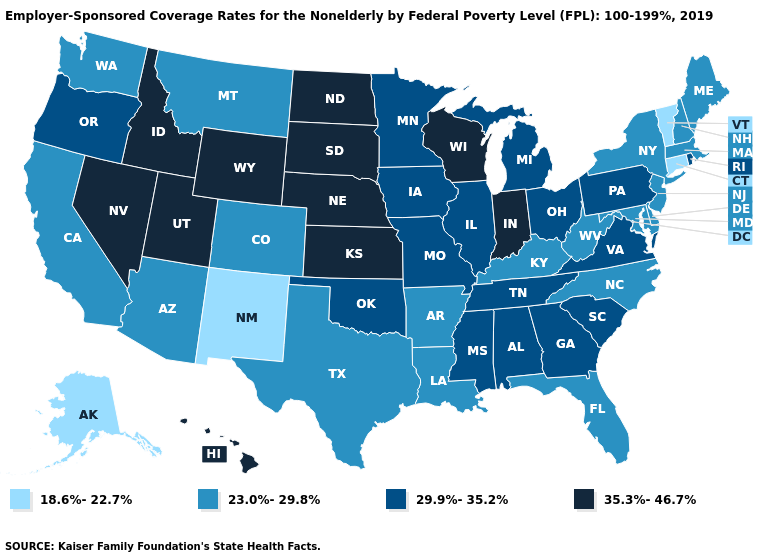How many symbols are there in the legend?
Short answer required. 4. How many symbols are there in the legend?
Answer briefly. 4. Which states have the highest value in the USA?
Be succinct. Hawaii, Idaho, Indiana, Kansas, Nebraska, Nevada, North Dakota, South Dakota, Utah, Wisconsin, Wyoming. What is the value of Oregon?
Write a very short answer. 29.9%-35.2%. Does Florida have the highest value in the South?
Be succinct. No. What is the value of New Jersey?
Short answer required. 23.0%-29.8%. What is the value of Georgia?
Write a very short answer. 29.9%-35.2%. What is the lowest value in the Northeast?
Answer briefly. 18.6%-22.7%. Is the legend a continuous bar?
Short answer required. No. Does the map have missing data?
Quick response, please. No. Among the states that border Rhode Island , does Massachusetts have the highest value?
Concise answer only. Yes. Which states have the highest value in the USA?
Answer briefly. Hawaii, Idaho, Indiana, Kansas, Nebraska, Nevada, North Dakota, South Dakota, Utah, Wisconsin, Wyoming. Name the states that have a value in the range 18.6%-22.7%?
Keep it brief. Alaska, Connecticut, New Mexico, Vermont. Does New York have a higher value than Connecticut?
Quick response, please. Yes. What is the value of Wisconsin?
Quick response, please. 35.3%-46.7%. 